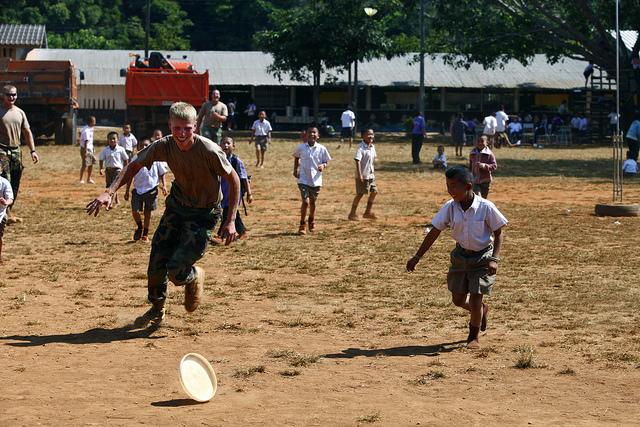Are two guys trying to catch the frisbee?
Keep it brief. Yes. What color are the boy's pants?
Answer briefly. Black. What job do the men in the picture do?
Quick response, please. Soldiers. Who is going to get to the frisbee first?
Quick response, please. Taller boy. What are the men wearing?
Answer briefly. Clothes. Which man has bad knees?
Concise answer only. None. What is the boy doing?
Answer briefly. Running. 